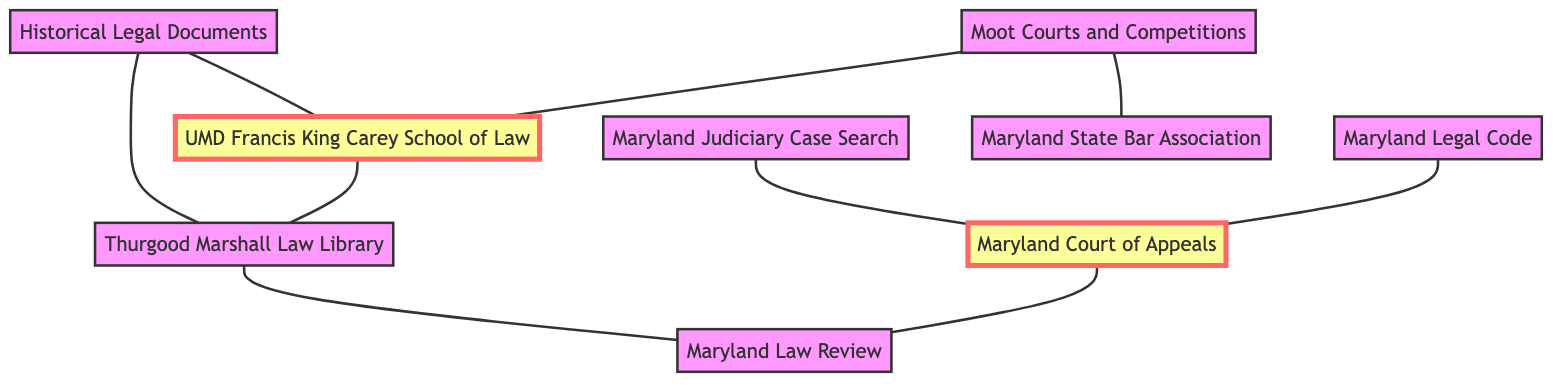What are the total number of nodes in the diagram? To determine the total number of nodes, we can count each unique entity listed in the data. In this case, there are 9 nodes: Maryland Legal Code, Maryland Court of Appeals, Maryland Law Review, Thurgood Marshall Law Library, University of Maryland Francis King Carey School of Law, Maryland Judiciary Case Search, Moot Courts and Competitions, Maryland State Bar Association, and Historical Legal Documents.
Answer: 9 Which nodes are directly connected to the Maryland Court of Appeals? By examining the edges connected to the Maryland Court of Appeals, we can see that it is connected to three nodes: Maryland Legal Code, Maryland Law Review, and Maryland Judiciary Case Search. Therefore, the question asks for a list of these directly connected nodes.
Answer: Maryland Legal Code, Maryland Law Review, Maryland Judiciary Case Search How many edges connect to the Thurgood Marshall Law Library? To find the number of edges connected to Thurgood Marshall Law Library, we look for all direct connections in the edges data. Thurgood Marshall Law Library has connections to two nodes: Maryland Law Review and the University of Maryland Francis King Carey School of Law, as well as connections from Historical Legal Documents. This results in a total of 3 edges.
Answer: 3 What is the relationship between Historical Legal Documents and the University of Maryland Francis King Carey School of Law? The relationship between these two nodes is one of a direct connection or edge. Historical Legal Documents is connected to the University of Maryland Francis King Carey School of Law, as indicated in the edges. Hence, they share an undirected edge in this undirected graph.
Answer: There is a direct connection Which node acts as a central hub connecting multiple resources in this diagram? The central hub in this scenario can be defined as the node with the highest number of connections. By examining the edges, the Maryland Court of Appeals connects to three nodes, and the University of Maryland Francis King Carey School of Law also connects to three nodes, but the Maryland State Bar Association connects to only two. Thus, the central hub here is the Maryland Court of Appeals, making it a significant resource in this diagram.
Answer: Maryland Court of Appeals What resources are associated with Moot Courts and Competitions? To answer this, we check the direct connections of the Moot Courts and Competitions node. It connects to two other nodes: the University of Maryland Francis King Carey School of Law and the Maryland State Bar Association. Thus, the answer includes both resources associated with this competition node.
Answer: University of Maryland Francis King Carey School of Law, Maryland State Bar Association 